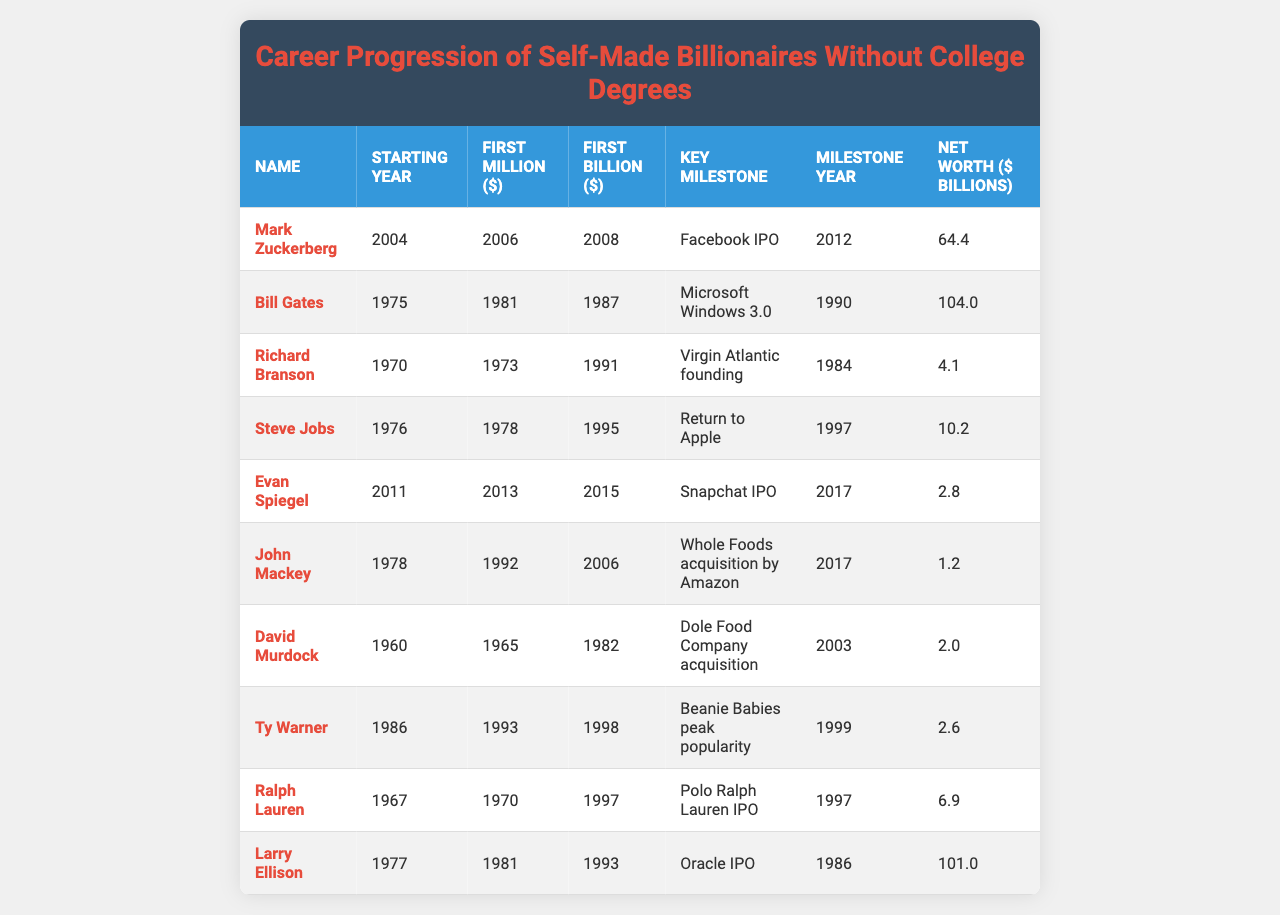What year did Mark Zuckerberg become a billionaire? According to the table, Mark Zuckerberg first became a billionaire in the year 2008.
Answer: 2008 How many billionaires had their first billion before 1990? By examining the table, the billionaires who first became billionaires before 1990 are Bill Gates, Richard Branson, Steve Jobs, David Murdock, and Larry Ellison. That totals to five billionaires.
Answer: 5 Who had the highest net worth and what was it? Reviewing the table, Bill Gates is listed with the highest net worth of 104.0 billion dollars.
Answer: 104.0 billion What was the key milestone for Ralph Lauren and when did it occur? The table indicates that Ralph Lauren's key milestone was the Polo Ralph Lauren IPO, which occurred in 1997.
Answer: Polo Ralph Lauren IPO, 1997 Which billionaire took the longest from starting their career to becoming a billionaire? By comparing the timeframes, John Mackey took the longest. He started in 1978 and became a billionaire in 2006, taking 28 years.
Answer: John Mackey What is the difference in years between the first million and first billion for Steve Jobs? From the table, Steve Jobs made his first million in 1978 and became a billionaire in 1995, which is a difference of 17 years (1995 - 1978 = 17).
Answer: 17 years Did any billionaire start their career after 2000? Evaluating the table, Evan Spiegel started his career in 2011, which confirms that there is at least one billionaire who began after 2000.
Answer: Yes What was the key milestone for Larry Ellison, and did it occur after 1990? The table states that Larry Ellison's key milestone was the Oracle IPO, which occurred in 1986, confirming it was before 1990.
Answer: Oracle IPO, No Who were the two billionaires with the closest first billion achievement years? Looking at the data, the closest years for achieving the first billion are Ralph Lauren (1997) and Ty Warner (1998), just one year apart.
Answer: Ralph Lauren and Ty Warner What is the average net worth of all the billionaires listed in the table? To find this average, we first sum their net worths (64.4 + 104.0 + 4.1 + 10.2 + 2.8 + 1.2 + 2.0 + 2.6 + 6.9 + 101.0 = 299.2) and then divide by the number of billionaires (10). The average is 299.2 / 10 = 29.92.
Answer: 29.92 billion Which billionaire became a billionaire the fastest and how long did it take? Mark Zuckerberg became a billionaire in 2008, just two years after starting in 2004, making it the fastest at 2 years.
Answer: Mark Zuckerberg, 2 years 